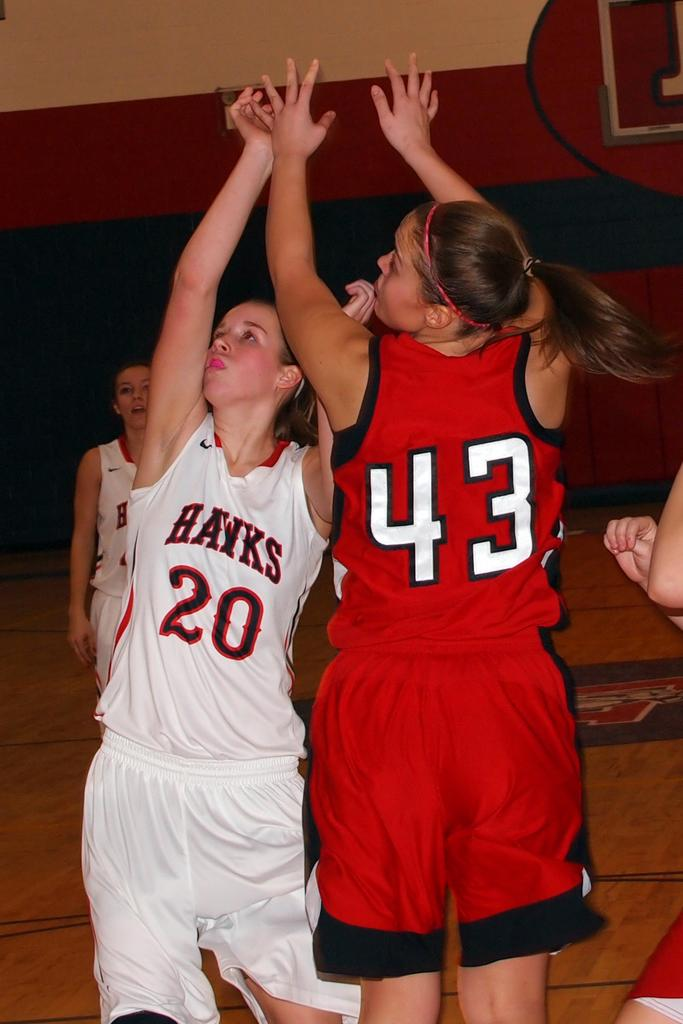<image>
Write a terse but informative summary of the picture. Basketball player wearing number 20 going for a rebound. 